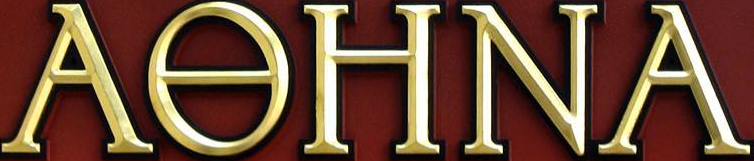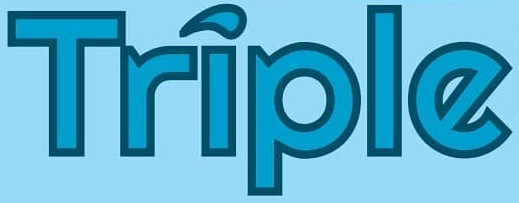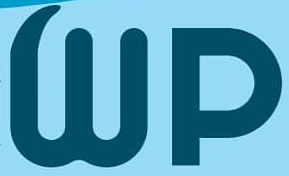What words are shown in these images in order, separated by a semicolon? AƟHNA; Triple; Wp 